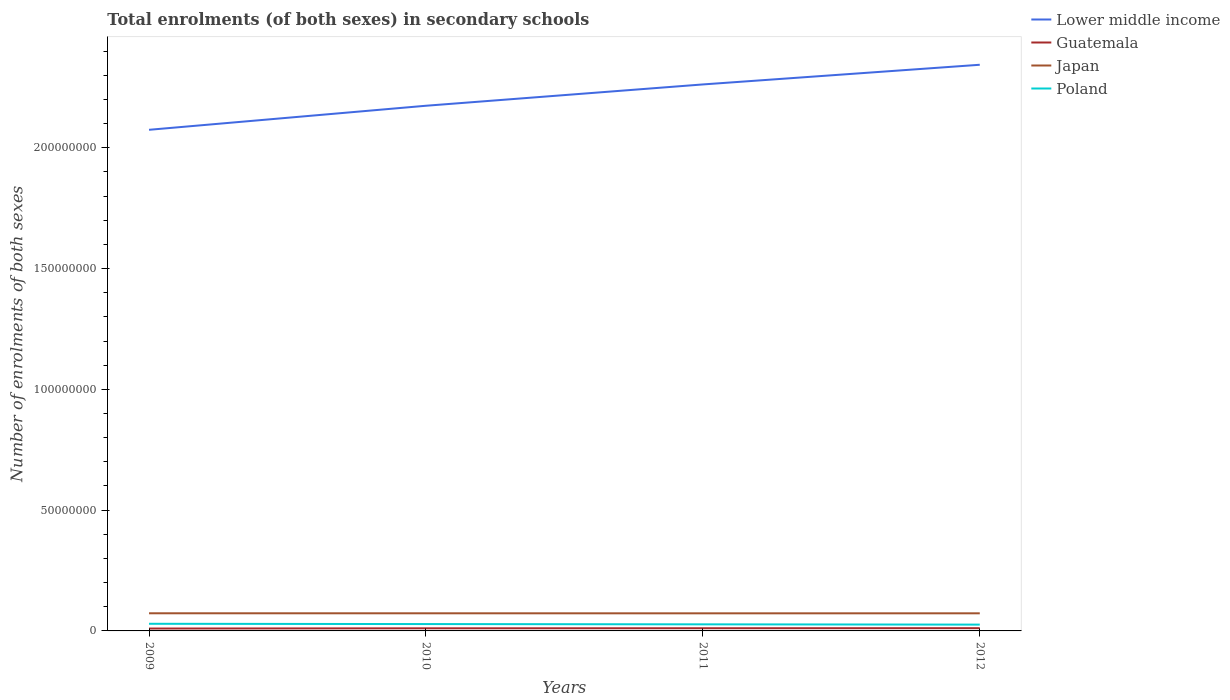How many different coloured lines are there?
Offer a terse response. 4. Does the line corresponding to Poland intersect with the line corresponding to Japan?
Your answer should be compact. No. Across all years, what is the maximum number of enrolments in secondary schools in Poland?
Your answer should be very brief. 2.61e+06. In which year was the number of enrolments in secondary schools in Japan maximum?
Provide a succinct answer. 2011. What is the total number of enrolments in secondary schools in Guatemala in the graph?
Provide a succinct answer. -1.31e+05. What is the difference between the highest and the second highest number of enrolments in secondary schools in Poland?
Provide a succinct answer. 3.47e+05. Is the number of enrolments in secondary schools in Poland strictly greater than the number of enrolments in secondary schools in Japan over the years?
Your answer should be very brief. Yes. Are the values on the major ticks of Y-axis written in scientific E-notation?
Offer a terse response. No. Where does the legend appear in the graph?
Provide a short and direct response. Top right. What is the title of the graph?
Provide a short and direct response. Total enrolments (of both sexes) in secondary schools. Does "Nigeria" appear as one of the legend labels in the graph?
Make the answer very short. No. What is the label or title of the X-axis?
Provide a short and direct response. Years. What is the label or title of the Y-axis?
Offer a terse response. Number of enrolments of both sexes. What is the Number of enrolments of both sexes of Lower middle income in 2009?
Provide a succinct answer. 2.07e+08. What is the Number of enrolments of both sexes in Guatemala in 2009?
Ensure brevity in your answer.  9.83e+05. What is the Number of enrolments of both sexes in Japan in 2009?
Keep it short and to the point. 7.30e+06. What is the Number of enrolments of both sexes in Poland in 2009?
Offer a very short reply. 2.96e+06. What is the Number of enrolments of both sexes in Lower middle income in 2010?
Keep it short and to the point. 2.17e+08. What is the Number of enrolments of both sexes in Guatemala in 2010?
Provide a succinct answer. 1.08e+06. What is the Number of enrolments of both sexes in Japan in 2010?
Provide a short and direct response. 7.30e+06. What is the Number of enrolments of both sexes in Poland in 2010?
Your answer should be compact. 2.84e+06. What is the Number of enrolments of both sexes in Lower middle income in 2011?
Your response must be concise. 2.26e+08. What is the Number of enrolments of both sexes in Guatemala in 2011?
Provide a short and direct response. 1.11e+06. What is the Number of enrolments of both sexes of Japan in 2011?
Offer a very short reply. 7.28e+06. What is the Number of enrolments of both sexes in Poland in 2011?
Offer a very short reply. 2.73e+06. What is the Number of enrolments of both sexes in Lower middle income in 2012?
Offer a terse response. 2.34e+08. What is the Number of enrolments of both sexes of Guatemala in 2012?
Keep it short and to the point. 1.14e+06. What is the Number of enrolments of both sexes in Japan in 2012?
Your answer should be very brief. 7.29e+06. What is the Number of enrolments of both sexes in Poland in 2012?
Offer a terse response. 2.61e+06. Across all years, what is the maximum Number of enrolments of both sexes of Lower middle income?
Ensure brevity in your answer.  2.34e+08. Across all years, what is the maximum Number of enrolments of both sexes of Guatemala?
Provide a short and direct response. 1.14e+06. Across all years, what is the maximum Number of enrolments of both sexes of Japan?
Keep it short and to the point. 7.30e+06. Across all years, what is the maximum Number of enrolments of both sexes of Poland?
Your answer should be very brief. 2.96e+06. Across all years, what is the minimum Number of enrolments of both sexes in Lower middle income?
Make the answer very short. 2.07e+08. Across all years, what is the minimum Number of enrolments of both sexes of Guatemala?
Your response must be concise. 9.83e+05. Across all years, what is the minimum Number of enrolments of both sexes of Japan?
Give a very brief answer. 7.28e+06. Across all years, what is the minimum Number of enrolments of both sexes of Poland?
Ensure brevity in your answer.  2.61e+06. What is the total Number of enrolments of both sexes of Lower middle income in the graph?
Keep it short and to the point. 8.86e+08. What is the total Number of enrolments of both sexes of Guatemala in the graph?
Offer a very short reply. 4.32e+06. What is the total Number of enrolments of both sexes of Japan in the graph?
Offer a very short reply. 2.92e+07. What is the total Number of enrolments of both sexes of Poland in the graph?
Keep it short and to the point. 1.11e+07. What is the difference between the Number of enrolments of both sexes in Lower middle income in 2009 and that in 2010?
Ensure brevity in your answer.  -9.96e+06. What is the difference between the Number of enrolments of both sexes in Guatemala in 2009 and that in 2010?
Give a very brief answer. -9.97e+04. What is the difference between the Number of enrolments of both sexes in Japan in 2009 and that in 2010?
Ensure brevity in your answer.  3636. What is the difference between the Number of enrolments of both sexes of Poland in 2009 and that in 2010?
Give a very brief answer. 1.17e+05. What is the difference between the Number of enrolments of both sexes in Lower middle income in 2009 and that in 2011?
Provide a short and direct response. -1.88e+07. What is the difference between the Number of enrolments of both sexes of Guatemala in 2009 and that in 2011?
Provide a succinct answer. -1.31e+05. What is the difference between the Number of enrolments of both sexes in Japan in 2009 and that in 2011?
Your response must be concise. 1.51e+04. What is the difference between the Number of enrolments of both sexes of Poland in 2009 and that in 2011?
Make the answer very short. 2.32e+05. What is the difference between the Number of enrolments of both sexes in Lower middle income in 2009 and that in 2012?
Provide a short and direct response. -2.69e+07. What is the difference between the Number of enrolments of both sexes of Guatemala in 2009 and that in 2012?
Ensure brevity in your answer.  -1.57e+05. What is the difference between the Number of enrolments of both sexes of Japan in 2009 and that in 2012?
Provide a short and direct response. 1.15e+04. What is the difference between the Number of enrolments of both sexes of Poland in 2009 and that in 2012?
Your answer should be compact. 3.47e+05. What is the difference between the Number of enrolments of both sexes in Lower middle income in 2010 and that in 2011?
Provide a succinct answer. -8.82e+06. What is the difference between the Number of enrolments of both sexes of Guatemala in 2010 and that in 2011?
Keep it short and to the point. -3.16e+04. What is the difference between the Number of enrolments of both sexes in Japan in 2010 and that in 2011?
Provide a short and direct response. 1.15e+04. What is the difference between the Number of enrolments of both sexes of Poland in 2010 and that in 2011?
Give a very brief answer. 1.15e+05. What is the difference between the Number of enrolments of both sexes in Lower middle income in 2010 and that in 2012?
Your answer should be compact. -1.70e+07. What is the difference between the Number of enrolments of both sexes of Guatemala in 2010 and that in 2012?
Provide a short and direct response. -5.72e+04. What is the difference between the Number of enrolments of both sexes of Japan in 2010 and that in 2012?
Provide a succinct answer. 7896. What is the difference between the Number of enrolments of both sexes in Poland in 2010 and that in 2012?
Make the answer very short. 2.31e+05. What is the difference between the Number of enrolments of both sexes of Lower middle income in 2011 and that in 2012?
Ensure brevity in your answer.  -8.14e+06. What is the difference between the Number of enrolments of both sexes of Guatemala in 2011 and that in 2012?
Your response must be concise. -2.57e+04. What is the difference between the Number of enrolments of both sexes in Japan in 2011 and that in 2012?
Keep it short and to the point. -3567. What is the difference between the Number of enrolments of both sexes in Poland in 2011 and that in 2012?
Make the answer very short. 1.15e+05. What is the difference between the Number of enrolments of both sexes of Lower middle income in 2009 and the Number of enrolments of both sexes of Guatemala in 2010?
Ensure brevity in your answer.  2.06e+08. What is the difference between the Number of enrolments of both sexes of Lower middle income in 2009 and the Number of enrolments of both sexes of Japan in 2010?
Ensure brevity in your answer.  2.00e+08. What is the difference between the Number of enrolments of both sexes of Lower middle income in 2009 and the Number of enrolments of both sexes of Poland in 2010?
Provide a succinct answer. 2.05e+08. What is the difference between the Number of enrolments of both sexes of Guatemala in 2009 and the Number of enrolments of both sexes of Japan in 2010?
Make the answer very short. -6.31e+06. What is the difference between the Number of enrolments of both sexes in Guatemala in 2009 and the Number of enrolments of both sexes in Poland in 2010?
Give a very brief answer. -1.86e+06. What is the difference between the Number of enrolments of both sexes in Japan in 2009 and the Number of enrolments of both sexes in Poland in 2010?
Provide a succinct answer. 4.46e+06. What is the difference between the Number of enrolments of both sexes of Lower middle income in 2009 and the Number of enrolments of both sexes of Guatemala in 2011?
Offer a very short reply. 2.06e+08. What is the difference between the Number of enrolments of both sexes of Lower middle income in 2009 and the Number of enrolments of both sexes of Japan in 2011?
Offer a terse response. 2.00e+08. What is the difference between the Number of enrolments of both sexes of Lower middle income in 2009 and the Number of enrolments of both sexes of Poland in 2011?
Give a very brief answer. 2.05e+08. What is the difference between the Number of enrolments of both sexes in Guatemala in 2009 and the Number of enrolments of both sexes in Japan in 2011?
Ensure brevity in your answer.  -6.30e+06. What is the difference between the Number of enrolments of both sexes in Guatemala in 2009 and the Number of enrolments of both sexes in Poland in 2011?
Make the answer very short. -1.74e+06. What is the difference between the Number of enrolments of both sexes in Japan in 2009 and the Number of enrolments of both sexes in Poland in 2011?
Offer a very short reply. 4.57e+06. What is the difference between the Number of enrolments of both sexes of Lower middle income in 2009 and the Number of enrolments of both sexes of Guatemala in 2012?
Ensure brevity in your answer.  2.06e+08. What is the difference between the Number of enrolments of both sexes in Lower middle income in 2009 and the Number of enrolments of both sexes in Japan in 2012?
Offer a terse response. 2.00e+08. What is the difference between the Number of enrolments of both sexes of Lower middle income in 2009 and the Number of enrolments of both sexes of Poland in 2012?
Your answer should be very brief. 2.05e+08. What is the difference between the Number of enrolments of both sexes of Guatemala in 2009 and the Number of enrolments of both sexes of Japan in 2012?
Offer a very short reply. -6.31e+06. What is the difference between the Number of enrolments of both sexes of Guatemala in 2009 and the Number of enrolments of both sexes of Poland in 2012?
Offer a very short reply. -1.63e+06. What is the difference between the Number of enrolments of both sexes in Japan in 2009 and the Number of enrolments of both sexes in Poland in 2012?
Give a very brief answer. 4.69e+06. What is the difference between the Number of enrolments of both sexes in Lower middle income in 2010 and the Number of enrolments of both sexes in Guatemala in 2011?
Your answer should be compact. 2.16e+08. What is the difference between the Number of enrolments of both sexes in Lower middle income in 2010 and the Number of enrolments of both sexes in Japan in 2011?
Make the answer very short. 2.10e+08. What is the difference between the Number of enrolments of both sexes in Lower middle income in 2010 and the Number of enrolments of both sexes in Poland in 2011?
Offer a very short reply. 2.15e+08. What is the difference between the Number of enrolments of both sexes in Guatemala in 2010 and the Number of enrolments of both sexes in Japan in 2011?
Your answer should be very brief. -6.20e+06. What is the difference between the Number of enrolments of both sexes of Guatemala in 2010 and the Number of enrolments of both sexes of Poland in 2011?
Your answer should be very brief. -1.64e+06. What is the difference between the Number of enrolments of both sexes in Japan in 2010 and the Number of enrolments of both sexes in Poland in 2011?
Your answer should be compact. 4.57e+06. What is the difference between the Number of enrolments of both sexes of Lower middle income in 2010 and the Number of enrolments of both sexes of Guatemala in 2012?
Make the answer very short. 2.16e+08. What is the difference between the Number of enrolments of both sexes in Lower middle income in 2010 and the Number of enrolments of both sexes in Japan in 2012?
Keep it short and to the point. 2.10e+08. What is the difference between the Number of enrolments of both sexes of Lower middle income in 2010 and the Number of enrolments of both sexes of Poland in 2012?
Your response must be concise. 2.15e+08. What is the difference between the Number of enrolments of both sexes of Guatemala in 2010 and the Number of enrolments of both sexes of Japan in 2012?
Offer a very short reply. -6.21e+06. What is the difference between the Number of enrolments of both sexes of Guatemala in 2010 and the Number of enrolments of both sexes of Poland in 2012?
Your answer should be compact. -1.53e+06. What is the difference between the Number of enrolments of both sexes of Japan in 2010 and the Number of enrolments of both sexes of Poland in 2012?
Offer a very short reply. 4.69e+06. What is the difference between the Number of enrolments of both sexes of Lower middle income in 2011 and the Number of enrolments of both sexes of Guatemala in 2012?
Your answer should be compact. 2.25e+08. What is the difference between the Number of enrolments of both sexes of Lower middle income in 2011 and the Number of enrolments of both sexes of Japan in 2012?
Provide a succinct answer. 2.19e+08. What is the difference between the Number of enrolments of both sexes of Lower middle income in 2011 and the Number of enrolments of both sexes of Poland in 2012?
Provide a succinct answer. 2.24e+08. What is the difference between the Number of enrolments of both sexes of Guatemala in 2011 and the Number of enrolments of both sexes of Japan in 2012?
Give a very brief answer. -6.17e+06. What is the difference between the Number of enrolments of both sexes in Guatemala in 2011 and the Number of enrolments of both sexes in Poland in 2012?
Your answer should be very brief. -1.50e+06. What is the difference between the Number of enrolments of both sexes in Japan in 2011 and the Number of enrolments of both sexes in Poland in 2012?
Your response must be concise. 4.67e+06. What is the average Number of enrolments of both sexes of Lower middle income per year?
Keep it short and to the point. 2.21e+08. What is the average Number of enrolments of both sexes of Guatemala per year?
Your response must be concise. 1.08e+06. What is the average Number of enrolments of both sexes of Japan per year?
Give a very brief answer. 7.29e+06. What is the average Number of enrolments of both sexes in Poland per year?
Keep it short and to the point. 2.78e+06. In the year 2009, what is the difference between the Number of enrolments of both sexes in Lower middle income and Number of enrolments of both sexes in Guatemala?
Offer a very short reply. 2.06e+08. In the year 2009, what is the difference between the Number of enrolments of both sexes in Lower middle income and Number of enrolments of both sexes in Japan?
Offer a very short reply. 2.00e+08. In the year 2009, what is the difference between the Number of enrolments of both sexes of Lower middle income and Number of enrolments of both sexes of Poland?
Ensure brevity in your answer.  2.05e+08. In the year 2009, what is the difference between the Number of enrolments of both sexes in Guatemala and Number of enrolments of both sexes in Japan?
Keep it short and to the point. -6.32e+06. In the year 2009, what is the difference between the Number of enrolments of both sexes in Guatemala and Number of enrolments of both sexes in Poland?
Provide a short and direct response. -1.98e+06. In the year 2009, what is the difference between the Number of enrolments of both sexes of Japan and Number of enrolments of both sexes of Poland?
Provide a short and direct response. 4.34e+06. In the year 2010, what is the difference between the Number of enrolments of both sexes of Lower middle income and Number of enrolments of both sexes of Guatemala?
Your answer should be compact. 2.16e+08. In the year 2010, what is the difference between the Number of enrolments of both sexes in Lower middle income and Number of enrolments of both sexes in Japan?
Offer a terse response. 2.10e+08. In the year 2010, what is the difference between the Number of enrolments of both sexes in Lower middle income and Number of enrolments of both sexes in Poland?
Provide a succinct answer. 2.15e+08. In the year 2010, what is the difference between the Number of enrolments of both sexes of Guatemala and Number of enrolments of both sexes of Japan?
Your answer should be very brief. -6.21e+06. In the year 2010, what is the difference between the Number of enrolments of both sexes of Guatemala and Number of enrolments of both sexes of Poland?
Provide a succinct answer. -1.76e+06. In the year 2010, what is the difference between the Number of enrolments of both sexes in Japan and Number of enrolments of both sexes in Poland?
Make the answer very short. 4.45e+06. In the year 2011, what is the difference between the Number of enrolments of both sexes in Lower middle income and Number of enrolments of both sexes in Guatemala?
Offer a very short reply. 2.25e+08. In the year 2011, what is the difference between the Number of enrolments of both sexes in Lower middle income and Number of enrolments of both sexes in Japan?
Your response must be concise. 2.19e+08. In the year 2011, what is the difference between the Number of enrolments of both sexes of Lower middle income and Number of enrolments of both sexes of Poland?
Give a very brief answer. 2.24e+08. In the year 2011, what is the difference between the Number of enrolments of both sexes in Guatemala and Number of enrolments of both sexes in Japan?
Keep it short and to the point. -6.17e+06. In the year 2011, what is the difference between the Number of enrolments of both sexes in Guatemala and Number of enrolments of both sexes in Poland?
Keep it short and to the point. -1.61e+06. In the year 2011, what is the difference between the Number of enrolments of both sexes of Japan and Number of enrolments of both sexes of Poland?
Provide a short and direct response. 4.56e+06. In the year 2012, what is the difference between the Number of enrolments of both sexes in Lower middle income and Number of enrolments of both sexes in Guatemala?
Provide a succinct answer. 2.33e+08. In the year 2012, what is the difference between the Number of enrolments of both sexes in Lower middle income and Number of enrolments of both sexes in Japan?
Provide a succinct answer. 2.27e+08. In the year 2012, what is the difference between the Number of enrolments of both sexes of Lower middle income and Number of enrolments of both sexes of Poland?
Make the answer very short. 2.32e+08. In the year 2012, what is the difference between the Number of enrolments of both sexes in Guatemala and Number of enrolments of both sexes in Japan?
Offer a very short reply. -6.15e+06. In the year 2012, what is the difference between the Number of enrolments of both sexes of Guatemala and Number of enrolments of both sexes of Poland?
Your response must be concise. -1.47e+06. In the year 2012, what is the difference between the Number of enrolments of both sexes of Japan and Number of enrolments of both sexes of Poland?
Keep it short and to the point. 4.68e+06. What is the ratio of the Number of enrolments of both sexes in Lower middle income in 2009 to that in 2010?
Your response must be concise. 0.95. What is the ratio of the Number of enrolments of both sexes in Guatemala in 2009 to that in 2010?
Make the answer very short. 0.91. What is the ratio of the Number of enrolments of both sexes in Poland in 2009 to that in 2010?
Your answer should be compact. 1.04. What is the ratio of the Number of enrolments of both sexes in Lower middle income in 2009 to that in 2011?
Offer a very short reply. 0.92. What is the ratio of the Number of enrolments of both sexes of Guatemala in 2009 to that in 2011?
Give a very brief answer. 0.88. What is the ratio of the Number of enrolments of both sexes in Japan in 2009 to that in 2011?
Your answer should be very brief. 1. What is the ratio of the Number of enrolments of both sexes of Poland in 2009 to that in 2011?
Provide a succinct answer. 1.09. What is the ratio of the Number of enrolments of both sexes in Lower middle income in 2009 to that in 2012?
Ensure brevity in your answer.  0.89. What is the ratio of the Number of enrolments of both sexes in Guatemala in 2009 to that in 2012?
Ensure brevity in your answer.  0.86. What is the ratio of the Number of enrolments of both sexes of Japan in 2009 to that in 2012?
Your response must be concise. 1. What is the ratio of the Number of enrolments of both sexes in Poland in 2009 to that in 2012?
Make the answer very short. 1.13. What is the ratio of the Number of enrolments of both sexes of Guatemala in 2010 to that in 2011?
Provide a short and direct response. 0.97. What is the ratio of the Number of enrolments of both sexes of Poland in 2010 to that in 2011?
Your response must be concise. 1.04. What is the ratio of the Number of enrolments of both sexes of Lower middle income in 2010 to that in 2012?
Offer a very short reply. 0.93. What is the ratio of the Number of enrolments of both sexes of Guatemala in 2010 to that in 2012?
Offer a terse response. 0.95. What is the ratio of the Number of enrolments of both sexes in Japan in 2010 to that in 2012?
Provide a succinct answer. 1. What is the ratio of the Number of enrolments of both sexes of Poland in 2010 to that in 2012?
Offer a terse response. 1.09. What is the ratio of the Number of enrolments of both sexes of Lower middle income in 2011 to that in 2012?
Make the answer very short. 0.97. What is the ratio of the Number of enrolments of both sexes in Guatemala in 2011 to that in 2012?
Your answer should be very brief. 0.98. What is the ratio of the Number of enrolments of both sexes in Japan in 2011 to that in 2012?
Provide a short and direct response. 1. What is the ratio of the Number of enrolments of both sexes of Poland in 2011 to that in 2012?
Offer a terse response. 1.04. What is the difference between the highest and the second highest Number of enrolments of both sexes in Lower middle income?
Your response must be concise. 8.14e+06. What is the difference between the highest and the second highest Number of enrolments of both sexes in Guatemala?
Keep it short and to the point. 2.57e+04. What is the difference between the highest and the second highest Number of enrolments of both sexes of Japan?
Keep it short and to the point. 3636. What is the difference between the highest and the second highest Number of enrolments of both sexes in Poland?
Your answer should be very brief. 1.17e+05. What is the difference between the highest and the lowest Number of enrolments of both sexes in Lower middle income?
Your response must be concise. 2.69e+07. What is the difference between the highest and the lowest Number of enrolments of both sexes in Guatemala?
Provide a succinct answer. 1.57e+05. What is the difference between the highest and the lowest Number of enrolments of both sexes of Japan?
Your answer should be very brief. 1.51e+04. What is the difference between the highest and the lowest Number of enrolments of both sexes in Poland?
Offer a terse response. 3.47e+05. 